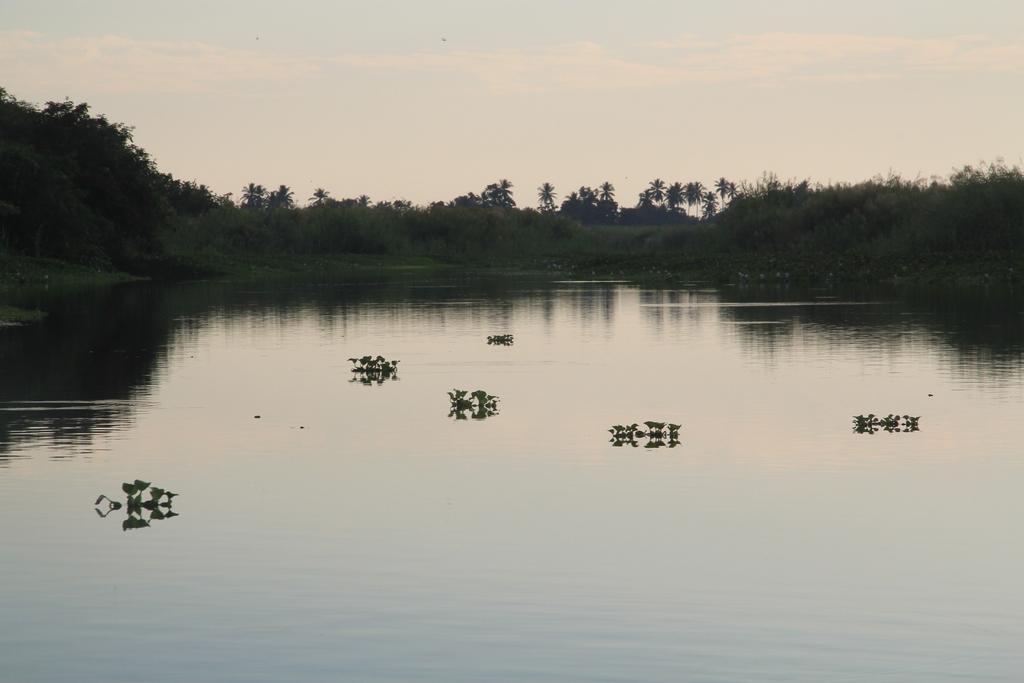In one or two sentences, can you explain what this image depicts? In this image at the bottom, there are plants and water. In the background there are trees, grass, sky, clouds. 